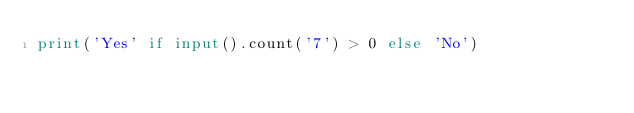Convert code to text. <code><loc_0><loc_0><loc_500><loc_500><_Python_>print('Yes' if input().count('7') > 0 else 'No')
</code> 